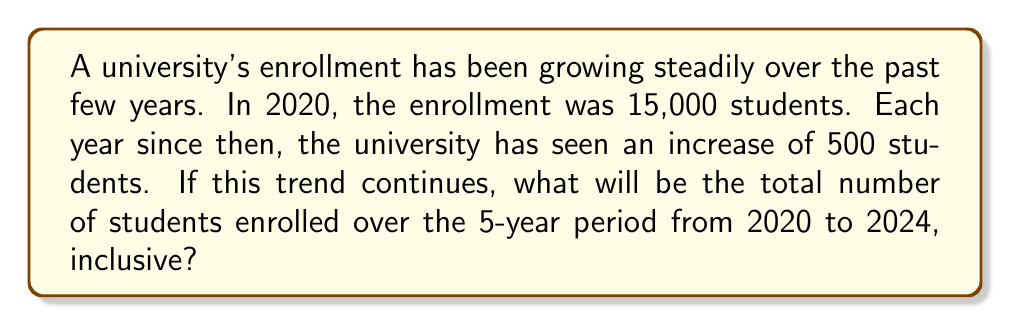Could you help me with this problem? Let's approach this step-by-step:

1) First, we need to identify the arithmetic sequence:
   - Initial term (2020 enrollment): $a_1 = 15,000$
   - Common difference: $d = 500$
   - Number of terms: $n = 5$ (2020, 2021, 2022, 2023, 2024)

2) The enrollment for each year can be calculated as follows:
   - 2020: $a_1 = 15,000$
   - 2021: $a_2 = a_1 + d = 15,000 + 500 = 15,500$
   - 2022: $a_3 = a_2 + d = 15,500 + 500 = 16,000$
   - 2023: $a_4 = a_3 + d = 16,000 + 500 = 16,500$
   - 2024: $a_5 = a_4 + d = 16,500 + 500 = 17,000$

3) To find the total number of students over the 5-year period, we need to sum this arithmetic sequence. We can use the formula for the sum of an arithmetic sequence:

   $S_n = \frac{n}{2}(a_1 + a_n)$

   Where:
   $S_n$ is the sum of the sequence
   $n$ is the number of terms
   $a_1$ is the first term
   $a_n$ is the last term

4) Plugging in our values:
   $S_5 = \frac{5}{2}(15,000 + 17,000)$

5) Simplifying:
   $S_5 = \frac{5}{2}(32,000) = 5 \times 16,000 = 80,000$

Therefore, the total number of students enrolled over the 5-year period will be 80,000.
Answer: 80,000 students 